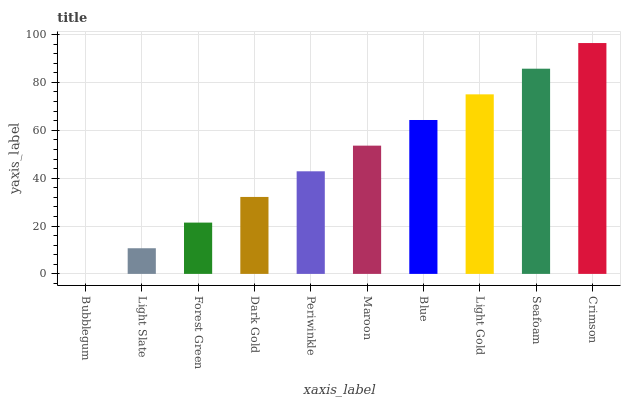Is Bubblegum the minimum?
Answer yes or no. Yes. Is Crimson the maximum?
Answer yes or no. Yes. Is Light Slate the minimum?
Answer yes or no. No. Is Light Slate the maximum?
Answer yes or no. No. Is Light Slate greater than Bubblegum?
Answer yes or no. Yes. Is Bubblegum less than Light Slate?
Answer yes or no. Yes. Is Bubblegum greater than Light Slate?
Answer yes or no. No. Is Light Slate less than Bubblegum?
Answer yes or no. No. Is Maroon the high median?
Answer yes or no. Yes. Is Periwinkle the low median?
Answer yes or no. Yes. Is Dark Gold the high median?
Answer yes or no. No. Is Crimson the low median?
Answer yes or no. No. 